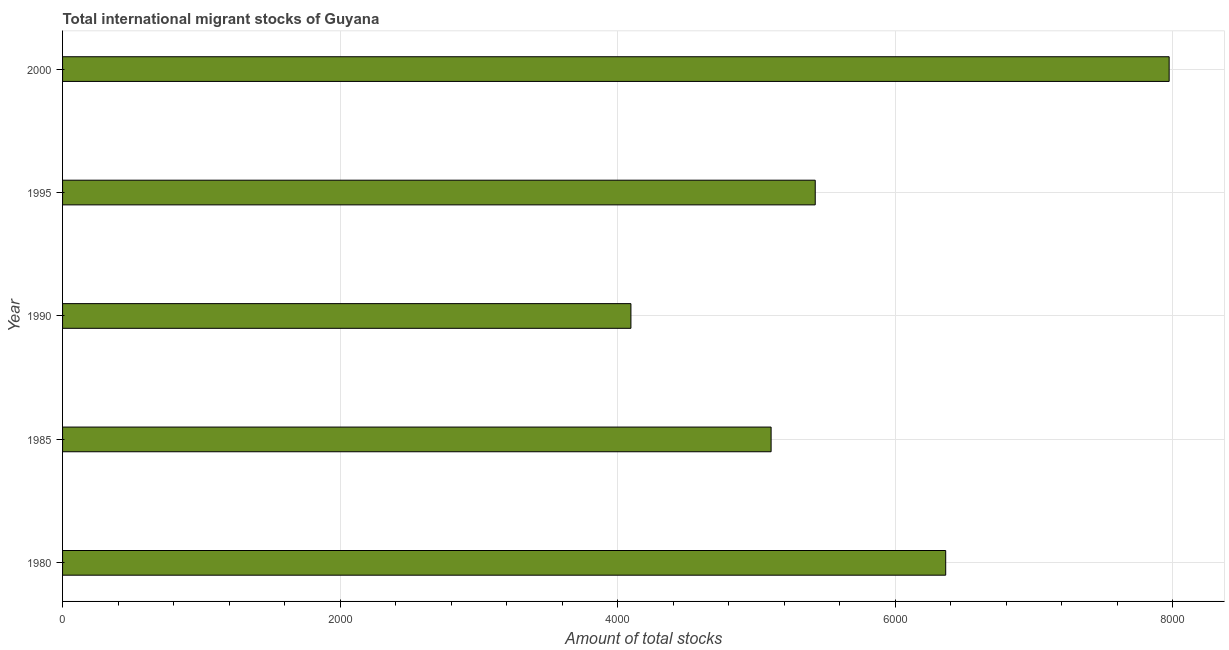Does the graph contain grids?
Provide a short and direct response. Yes. What is the title of the graph?
Ensure brevity in your answer.  Total international migrant stocks of Guyana. What is the label or title of the X-axis?
Your answer should be compact. Amount of total stocks. What is the label or title of the Y-axis?
Offer a very short reply. Year. What is the total number of international migrant stock in 1990?
Your answer should be very brief. 4095. Across all years, what is the maximum total number of international migrant stock?
Offer a very short reply. 7973. Across all years, what is the minimum total number of international migrant stock?
Provide a short and direct response. 4095. In which year was the total number of international migrant stock maximum?
Give a very brief answer. 2000. In which year was the total number of international migrant stock minimum?
Your response must be concise. 1990. What is the sum of the total number of international migrant stock?
Your response must be concise. 2.90e+04. What is the difference between the total number of international migrant stock in 1985 and 2000?
Provide a short and direct response. -2868. What is the average total number of international migrant stock per year?
Give a very brief answer. 5791. What is the median total number of international migrant stock?
Make the answer very short. 5423. Do a majority of the years between 1990 and 1980 (inclusive) have total number of international migrant stock greater than 6400 ?
Your answer should be compact. Yes. What is the ratio of the total number of international migrant stock in 1980 to that in 1990?
Your answer should be compact. 1.55. Is the total number of international migrant stock in 1980 less than that in 1995?
Offer a very short reply. No. What is the difference between the highest and the second highest total number of international migrant stock?
Provide a succinct answer. 1610. Is the sum of the total number of international migrant stock in 1995 and 2000 greater than the maximum total number of international migrant stock across all years?
Provide a succinct answer. Yes. What is the difference between the highest and the lowest total number of international migrant stock?
Keep it short and to the point. 3878. How many bars are there?
Your answer should be compact. 5. How many years are there in the graph?
Keep it short and to the point. 5. What is the difference between two consecutive major ticks on the X-axis?
Your answer should be very brief. 2000. Are the values on the major ticks of X-axis written in scientific E-notation?
Your response must be concise. No. What is the Amount of total stocks of 1980?
Your response must be concise. 6363. What is the Amount of total stocks of 1985?
Your answer should be compact. 5105. What is the Amount of total stocks of 1990?
Offer a terse response. 4095. What is the Amount of total stocks of 1995?
Your response must be concise. 5423. What is the Amount of total stocks of 2000?
Provide a succinct answer. 7973. What is the difference between the Amount of total stocks in 1980 and 1985?
Your answer should be compact. 1258. What is the difference between the Amount of total stocks in 1980 and 1990?
Offer a terse response. 2268. What is the difference between the Amount of total stocks in 1980 and 1995?
Offer a very short reply. 940. What is the difference between the Amount of total stocks in 1980 and 2000?
Offer a very short reply. -1610. What is the difference between the Amount of total stocks in 1985 and 1990?
Provide a short and direct response. 1010. What is the difference between the Amount of total stocks in 1985 and 1995?
Your answer should be compact. -318. What is the difference between the Amount of total stocks in 1985 and 2000?
Your answer should be very brief. -2868. What is the difference between the Amount of total stocks in 1990 and 1995?
Offer a terse response. -1328. What is the difference between the Amount of total stocks in 1990 and 2000?
Your answer should be very brief. -3878. What is the difference between the Amount of total stocks in 1995 and 2000?
Your response must be concise. -2550. What is the ratio of the Amount of total stocks in 1980 to that in 1985?
Give a very brief answer. 1.25. What is the ratio of the Amount of total stocks in 1980 to that in 1990?
Your response must be concise. 1.55. What is the ratio of the Amount of total stocks in 1980 to that in 1995?
Ensure brevity in your answer.  1.17. What is the ratio of the Amount of total stocks in 1980 to that in 2000?
Give a very brief answer. 0.8. What is the ratio of the Amount of total stocks in 1985 to that in 1990?
Offer a terse response. 1.25. What is the ratio of the Amount of total stocks in 1985 to that in 1995?
Your response must be concise. 0.94. What is the ratio of the Amount of total stocks in 1985 to that in 2000?
Your answer should be compact. 0.64. What is the ratio of the Amount of total stocks in 1990 to that in 1995?
Ensure brevity in your answer.  0.76. What is the ratio of the Amount of total stocks in 1990 to that in 2000?
Your response must be concise. 0.51. What is the ratio of the Amount of total stocks in 1995 to that in 2000?
Give a very brief answer. 0.68. 